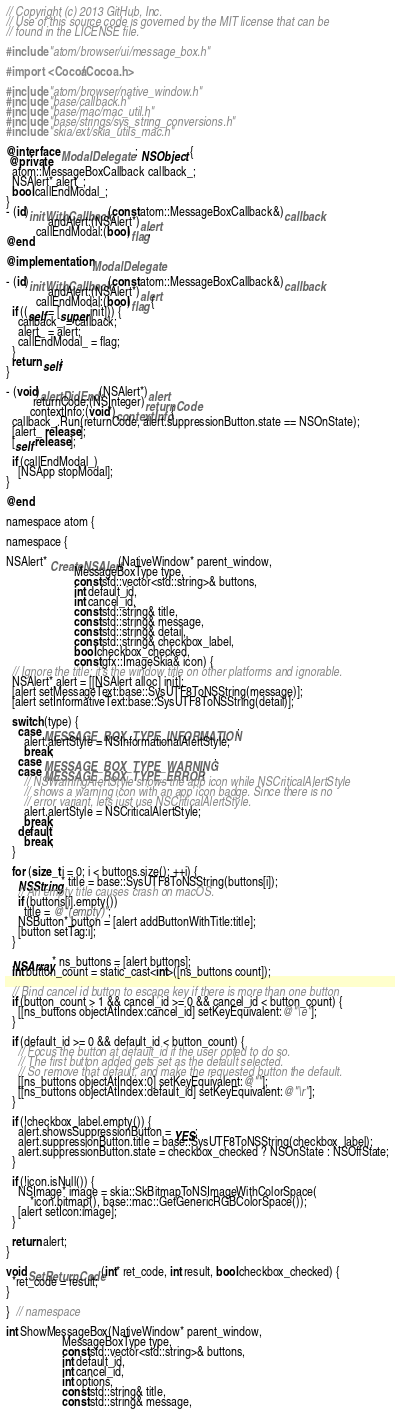Convert code to text. <code><loc_0><loc_0><loc_500><loc_500><_ObjectiveC_>// Copyright (c) 2013 GitHub, Inc.
// Use of this source code is governed by the MIT license that can be
// found in the LICENSE file.

#include "atom/browser/ui/message_box.h"

#import <Cocoa/Cocoa.h>

#include "atom/browser/native_window.h"
#include "base/callback.h"
#include "base/mac/mac_util.h"
#include "base/strings/sys_string_conversions.h"
#include "skia/ext/skia_utils_mac.h"

@interface ModalDelegate : NSObject {
 @private
  atom::MessageBoxCallback callback_;
  NSAlert* alert_;
  bool callEndModal_;
}
- (id)initWithCallback:(const atom::MessageBoxCallback&)callback
              andAlert:(NSAlert*)alert
          callEndModal:(bool)flag;
@end

@implementation ModalDelegate

- (id)initWithCallback:(const atom::MessageBoxCallback&)callback
              andAlert:(NSAlert*)alert
          callEndModal:(bool)flag {
  if ((self = [super init])) {
    callback_ = callback;
    alert_ = alert;
    callEndModal_ = flag;
  }
  return self;
}

- (void)alertDidEnd:(NSAlert*)alert
         returnCode:(NSInteger)returnCode
        contextInfo:(void*)contextInfo {
  callback_.Run(returnCode, alert.suppressionButton.state == NSOnState);
  [alert_ release];
  [self release];

  if (callEndModal_)
    [NSApp stopModal];
}

@end

namespace atom {

namespace {

NSAlert* CreateNSAlert(NativeWindow* parent_window,
                       MessageBoxType type,
                       const std::vector<std::string>& buttons,
                       int default_id,
                       int cancel_id,
                       const std::string& title,
                       const std::string& message,
                       const std::string& detail,
                       const std::string& checkbox_label,
                       bool checkbox_checked,
                       const gfx::ImageSkia& icon) {
  // Ignore the title; it's the window title on other platforms and ignorable.
  NSAlert* alert = [[NSAlert alloc] init];
  [alert setMessageText:base::SysUTF8ToNSString(message)];
  [alert setInformativeText:base::SysUTF8ToNSString(detail)];

  switch (type) {
    case MESSAGE_BOX_TYPE_INFORMATION:
      alert.alertStyle = NSInformationalAlertStyle;
      break;
    case MESSAGE_BOX_TYPE_WARNING:
    case MESSAGE_BOX_TYPE_ERROR:
      // NSWarningAlertStyle shows the app icon while NSCriticalAlertStyle
      // shows a warning icon with an app icon badge. Since there is no
      // error variant, lets just use NSCriticalAlertStyle.
      alert.alertStyle = NSCriticalAlertStyle;
      break;
    default:
      break;
  }

  for (size_t i = 0; i < buttons.size(); ++i) {
    NSString* title = base::SysUTF8ToNSString(buttons[i]);
    // An empty title causes crash on macOS.
    if (buttons[i].empty())
      title = @"(empty)";
    NSButton* button = [alert addButtonWithTitle:title];
    [button setTag:i];
  }

  NSArray* ns_buttons = [alert buttons];
  int button_count = static_cast<int>([ns_buttons count]);

  // Bind cancel id button to escape key if there is more than one button
  if (button_count > 1 && cancel_id >= 0 && cancel_id < button_count) {
    [[ns_buttons objectAtIndex:cancel_id] setKeyEquivalent:@"\e"];
  }

  if (default_id >= 0 && default_id < button_count) {
    // Focus the button at default_id if the user opted to do so.
    // The first button added gets set as the default selected.
    // So remove that default, and make the requested button the default.
    [[ns_buttons objectAtIndex:0] setKeyEquivalent:@""];
    [[ns_buttons objectAtIndex:default_id] setKeyEquivalent:@"\r"];
  }

  if (!checkbox_label.empty()) {
    alert.showsSuppressionButton = YES;
    alert.suppressionButton.title = base::SysUTF8ToNSString(checkbox_label);
    alert.suppressionButton.state = checkbox_checked ? NSOnState : NSOffState;
  }

  if (!icon.isNull()) {
    NSImage* image = skia::SkBitmapToNSImageWithColorSpace(
        *icon.bitmap(), base::mac::GetGenericRGBColorSpace());
    [alert setIcon:image];
  }

  return alert;
}

void SetReturnCode(int* ret_code, int result, bool checkbox_checked) {
  *ret_code = result;
}

}  // namespace

int ShowMessageBox(NativeWindow* parent_window,
                   MessageBoxType type,
                   const std::vector<std::string>& buttons,
                   int default_id,
                   int cancel_id,
                   int options,
                   const std::string& title,
                   const std::string& message,</code> 